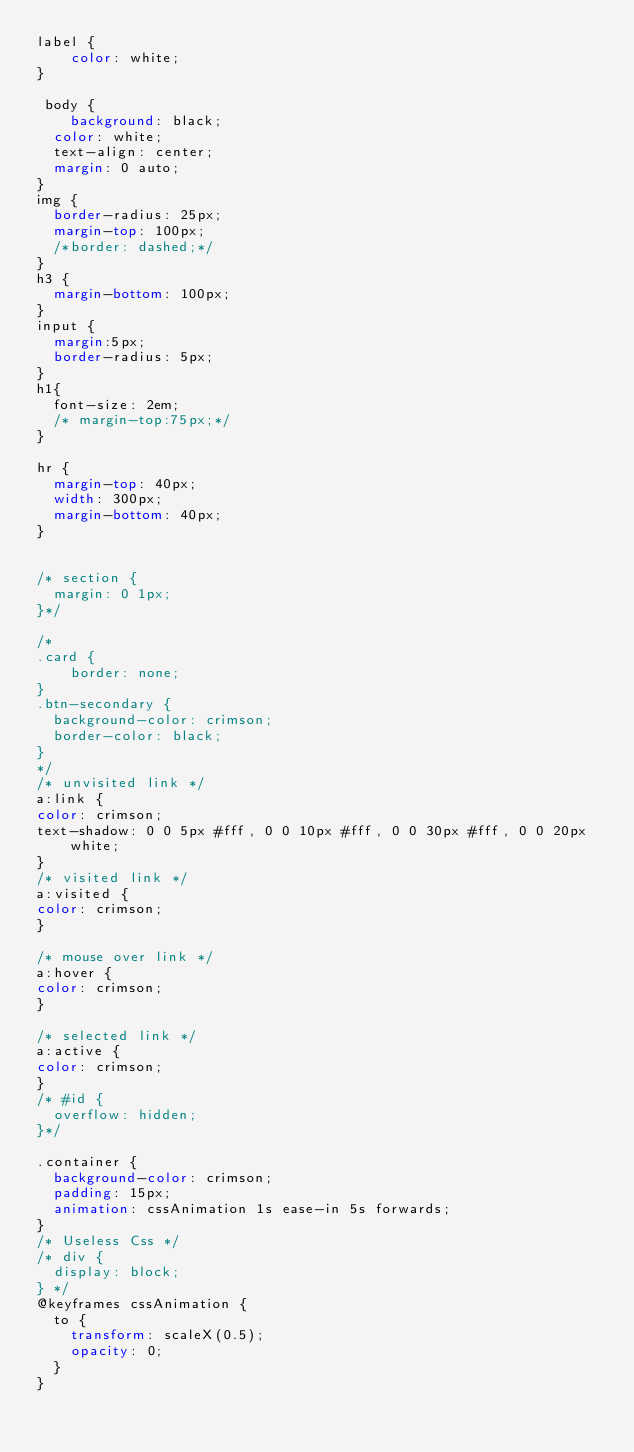Convert code to text. <code><loc_0><loc_0><loc_500><loc_500><_CSS_>label {
    color: white;
}

 body {
    background: black;
  color: white;
  text-align: center;
  margin: 0 auto;
}
img {
  border-radius: 25px;
  margin-top: 100px;
  /*border: dashed;*/
}
h3 {
  margin-bottom: 100px;
}
input {
  margin:5px;
  border-radius: 5px;
}
h1{
  font-size: 2em;
  /* margin-top:75px;*/
}

hr {
  margin-top: 40px;
  width: 300px;
  margin-bottom: 40px;
}


/* section {
  margin: 0 1px;
}*/

/*
.card {
    border: none;
}
.btn-secondary {
  background-color: crimson;
  border-color: black;
}
*/
/* unvisited link */
a:link {
color: crimson;
text-shadow: 0 0 5px #fff, 0 0 10px #fff, 0 0 30px #fff, 0 0 20px white;
}
/* visited link */
a:visited {
color: crimson;
}

/* mouse over link */
a:hover {
color: crimson;
}

/* selected link */
a:active {
color: crimson;
}
/* #id {
  overflow: hidden;
}*/

.container {
  background-color: crimson;
  padding: 15px;
  animation: cssAnimation 1s ease-in 5s forwards;
}
/* Useless Css */
/* div {
  display: block;
} */
@keyframes cssAnimation {
  to {
    transform: scaleX(0.5);
    opacity: 0;
  }
}</code> 